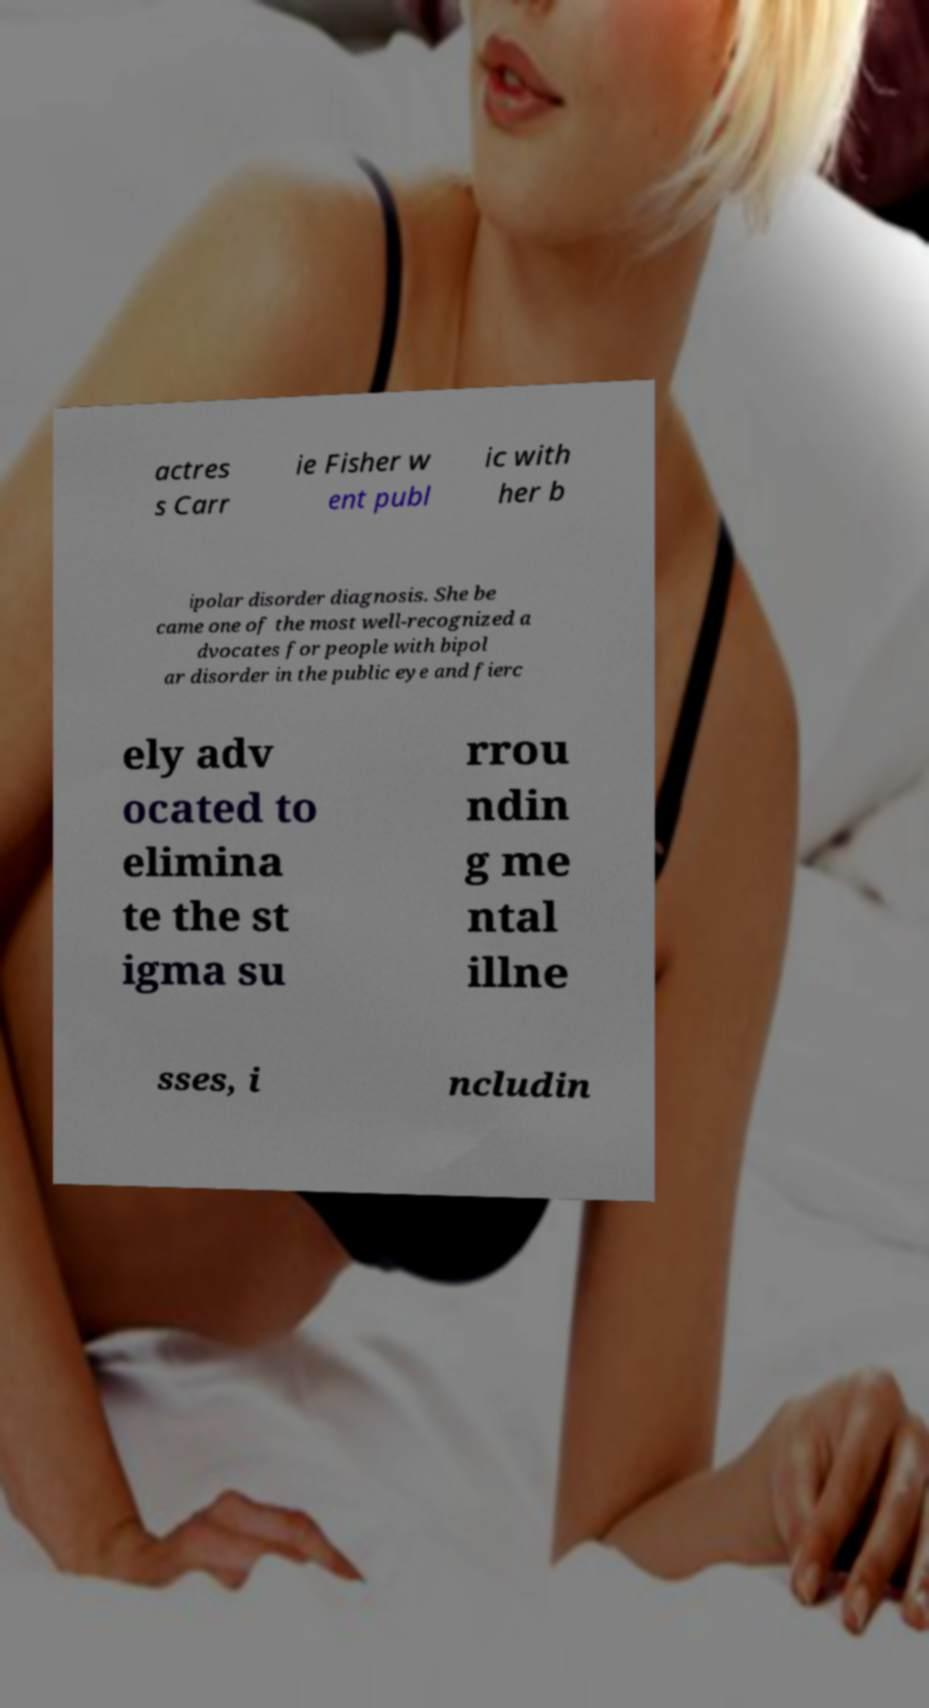Please identify and transcribe the text found in this image. actres s Carr ie Fisher w ent publ ic with her b ipolar disorder diagnosis. She be came one of the most well-recognized a dvocates for people with bipol ar disorder in the public eye and fierc ely adv ocated to elimina te the st igma su rrou ndin g me ntal illne sses, i ncludin 